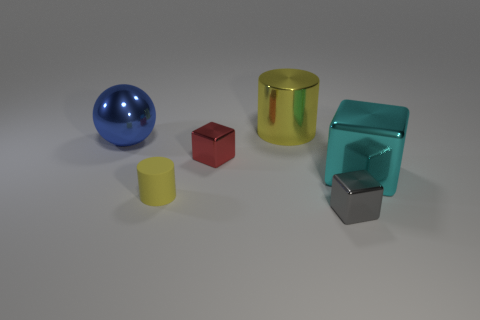Are there any other things that have the same color as the big cube?
Offer a terse response. No. There is a small thing that is behind the large thing that is in front of the tiny red metal block; is there a small red cube behind it?
Give a very brief answer. No. Do the cylinder that is behind the large blue metal thing and the small cylinder have the same color?
Your answer should be compact. Yes. What number of cubes are either small gray objects or large things?
Give a very brief answer. 2. The small metal thing on the left side of the small block that is on the right side of the shiny cylinder is what shape?
Offer a terse response. Cube. What is the size of the cube that is to the left of the small shiny object that is to the right of the small thing that is behind the big cyan metallic cube?
Keep it short and to the point. Small. Is the size of the metallic sphere the same as the shiny cylinder?
Make the answer very short. Yes. How many objects are either red metallic cubes or metal cylinders?
Provide a succinct answer. 2. How big is the yellow thing that is to the left of the tiny cube on the left side of the large cylinder?
Make the answer very short. Small. The yellow shiny cylinder has what size?
Your response must be concise. Large. 